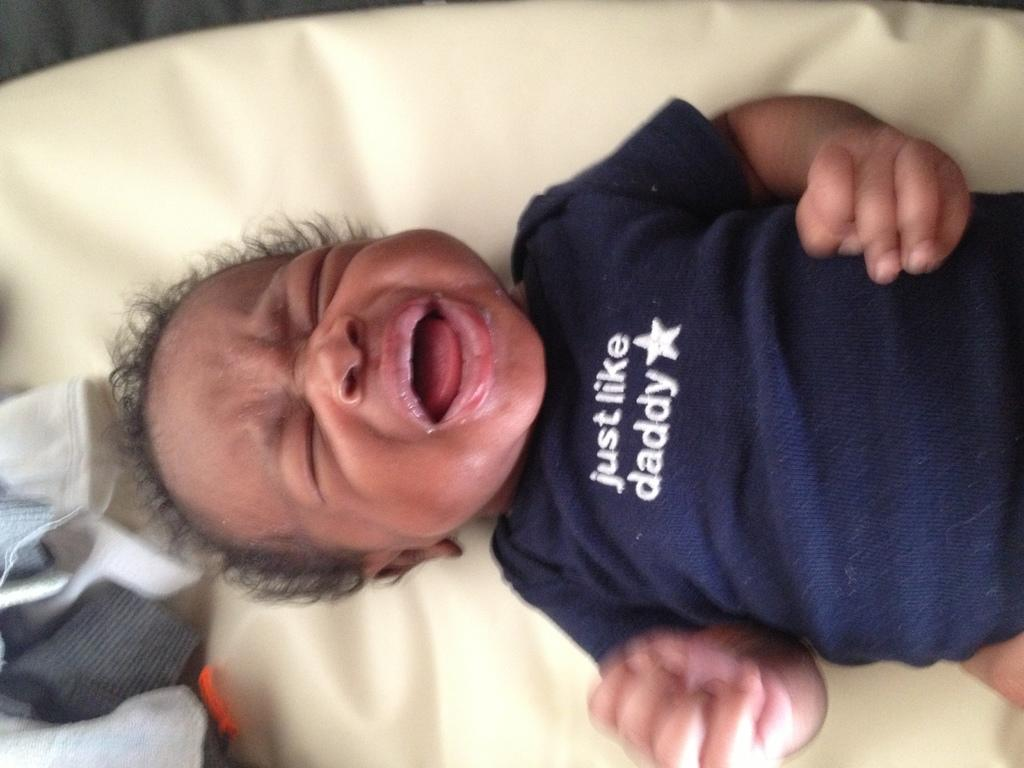What is the main subject of the image? The main subject of the image is a kid. What is the kid doing in the image? The kid is lying on an object. Are there any other items visible in the image? Yes, there are clothes visible in the bottom left of the image. What type of brick can be seen in the image? There is no brick present in the image. How many clovers are visible in the image? There are no clovers present in the image. 